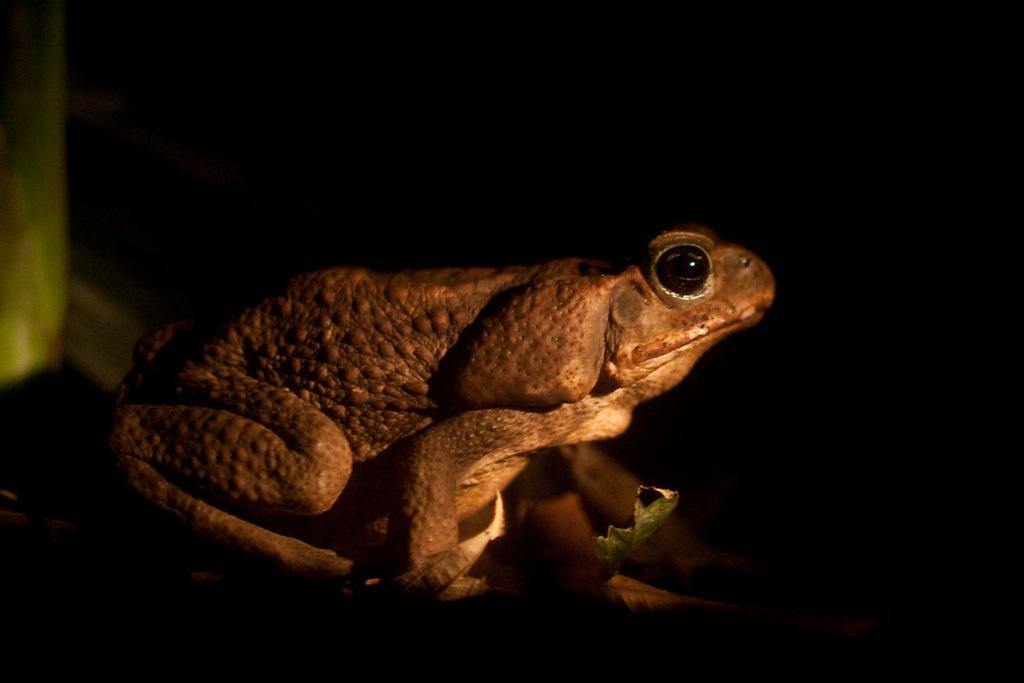What type of animal is in the image? There is a frog in the image. What color is the frog? The frog is brown in color. What can be observed about the background of the image? The background of the image is dark. What type of organization does the man in the image belong to? There is no man present in the image, only a brown frog. Can you tell me the name of the kitty in the image? There is no kitty present in the image, only a brown frog. 